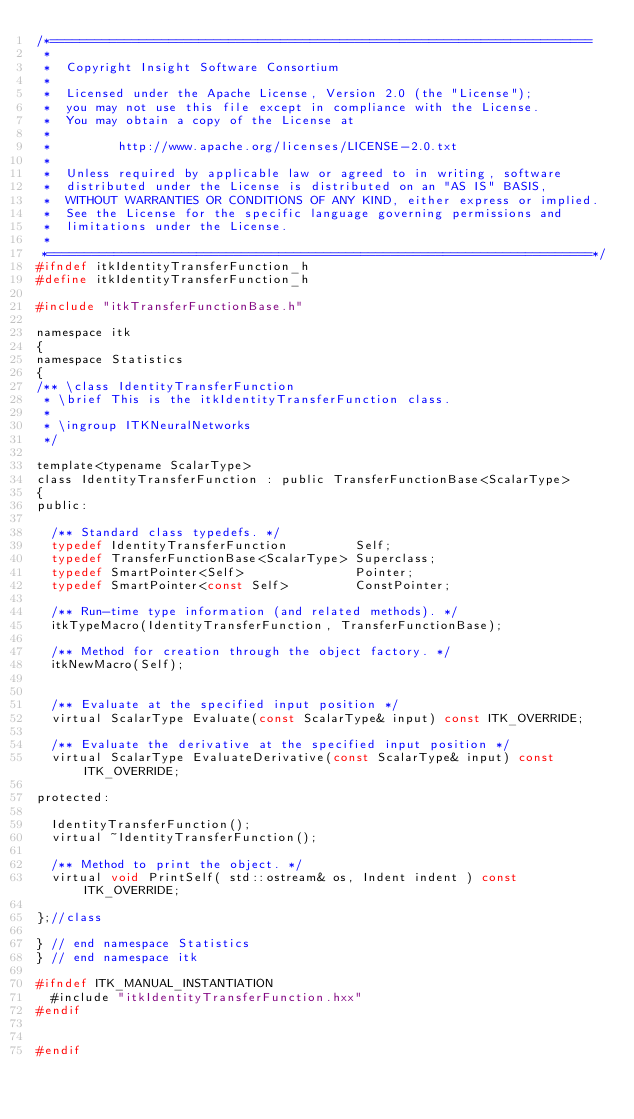Convert code to text. <code><loc_0><loc_0><loc_500><loc_500><_C_>/*=========================================================================
 *
 *  Copyright Insight Software Consortium
 *
 *  Licensed under the Apache License, Version 2.0 (the "License");
 *  you may not use this file except in compliance with the License.
 *  You may obtain a copy of the License at
 *
 *         http://www.apache.org/licenses/LICENSE-2.0.txt
 *
 *  Unless required by applicable law or agreed to in writing, software
 *  distributed under the License is distributed on an "AS IS" BASIS,
 *  WITHOUT WARRANTIES OR CONDITIONS OF ANY KIND, either express or implied.
 *  See the License for the specific language governing permissions and
 *  limitations under the License.
 *
 *=========================================================================*/
#ifndef itkIdentityTransferFunction_h
#define itkIdentityTransferFunction_h

#include "itkTransferFunctionBase.h"

namespace itk
{
namespace Statistics
{
/** \class IdentityTransferFunction
 * \brief This is the itkIdentityTransferFunction class.
 *
 * \ingroup ITKNeuralNetworks
 */

template<typename ScalarType>
class IdentityTransferFunction : public TransferFunctionBase<ScalarType>
{
public:

  /** Standard class typedefs. */
  typedef IdentityTransferFunction         Self;
  typedef TransferFunctionBase<ScalarType> Superclass;
  typedef SmartPointer<Self>               Pointer;
  typedef SmartPointer<const Self>         ConstPointer;

  /** Run-time type information (and related methods). */
  itkTypeMacro(IdentityTransferFunction, TransferFunctionBase);

  /** Method for creation through the object factory. */
  itkNewMacro(Self);


  /** Evaluate at the specified input position */
  virtual ScalarType Evaluate(const ScalarType& input) const ITK_OVERRIDE;

  /** Evaluate the derivative at the specified input position */
  virtual ScalarType EvaluateDerivative(const ScalarType& input) const ITK_OVERRIDE;

protected:

  IdentityTransferFunction();
  virtual ~IdentityTransferFunction();

  /** Method to print the object. */
  virtual void PrintSelf( std::ostream& os, Indent indent ) const ITK_OVERRIDE;

};//class

} // end namespace Statistics
} // end namespace itk

#ifndef ITK_MANUAL_INSTANTIATION
  #include "itkIdentityTransferFunction.hxx"
#endif


#endif
</code> 